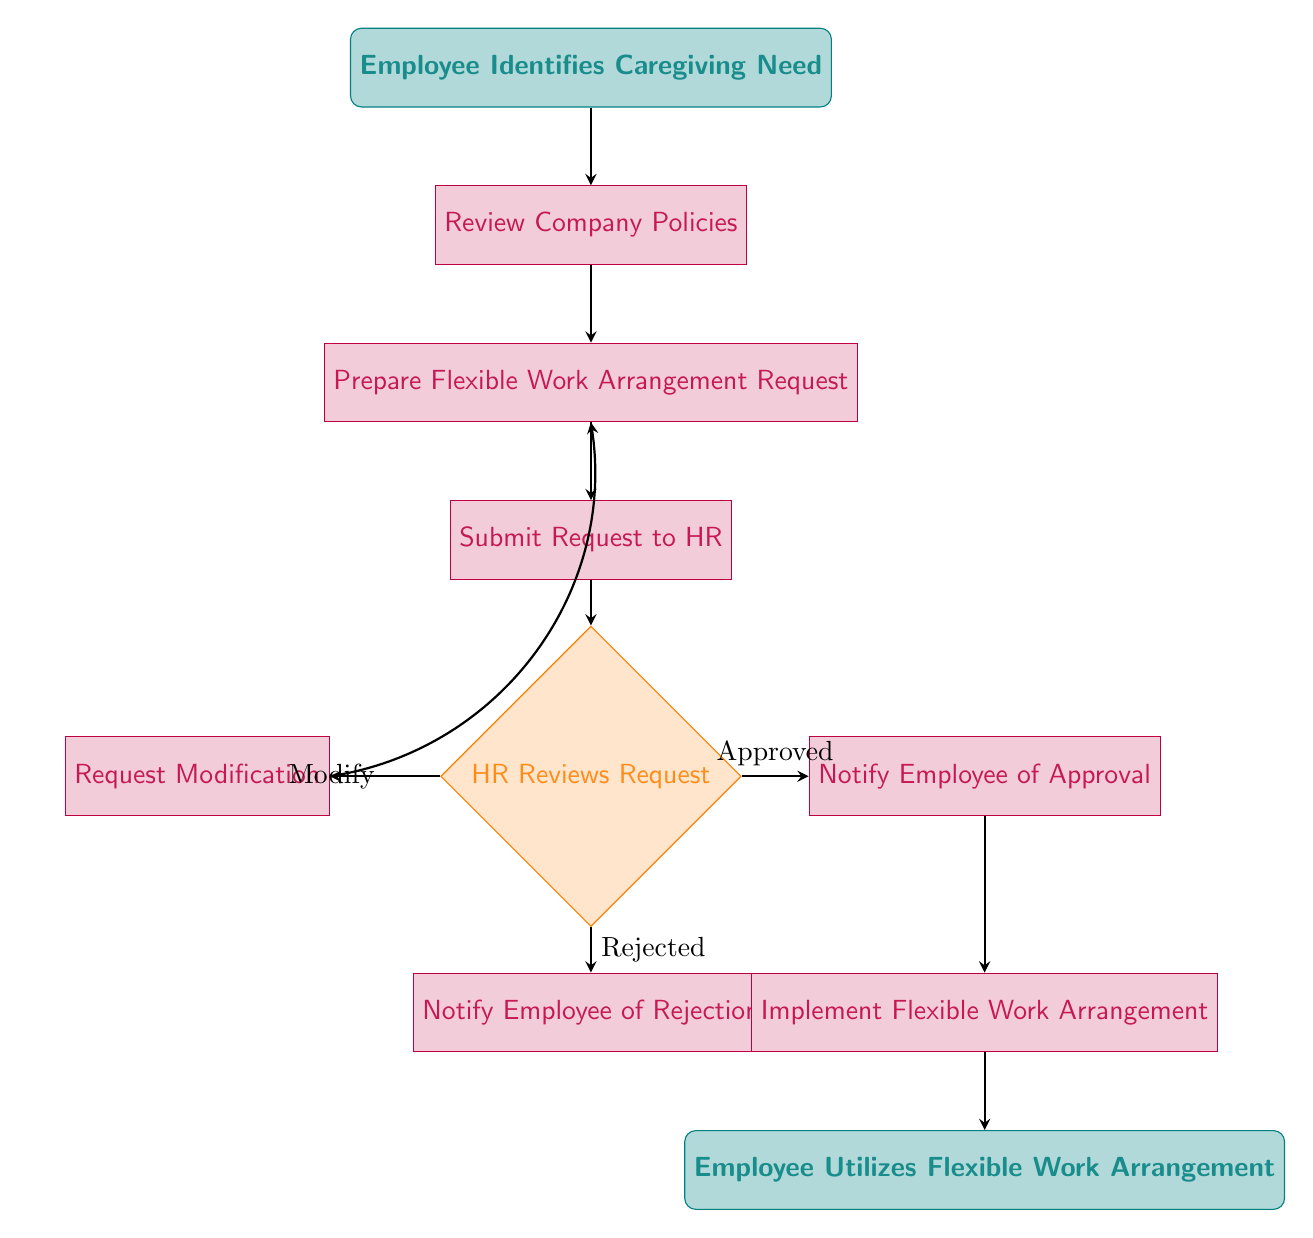What is the first step in the process? The first step in the process is identified by the start node labeled "Employee Identifies Caregiving Need." This node marks the beginning of the flow chart and indicates what action the employee takes initially.
Answer: Employee Identifies Caregiving Need How many decision points are in the flow chart? There is only one decision point in the flow chart, which is represented by the node labeled "HR Reviews Request." This node indicates that the HR department evaluates the request made by the employee.
Answer: 1 What happens if the HR reviews the request and approves it? If the HR reviews the request and approves it, the flow chart indicates that the next step is "Notify Employee of Approval." This is a direct flow from the decision point labeled "Approved" toward this processing step.
Answer: Notify Employee of Approval What is the relationship between the nodes “Request Modification” and “Prepare Flexible Work Arrangement Request”? The node labeled "Request Modification" has a direct flow back to the node "Prepare Flexible Work Arrangement Request." This indicates that after a modification request, the employee must go back to the preparation step to adjust their request accordingly.
Answer: Feedback loop What occurs after the employee is notified of approval? After the employee is notified of approval, the next step in the process is to "Implement Flexible Work Arrangement." This indicates the actions taken by HR or the organization to put the approved arrangement into effect after communicating approval to the employee.
Answer: Implement Flexible Work Arrangement What is the final step in the diagram? The final step in the diagram is designated by the end node labeled "Employee Utilizes Flexible Work Arrangement." This indicates that the process concludes once the employee starts to use the flexible work arrangement that has been established.
Answer: Employee Utilizes Flexible Work Arrangement 